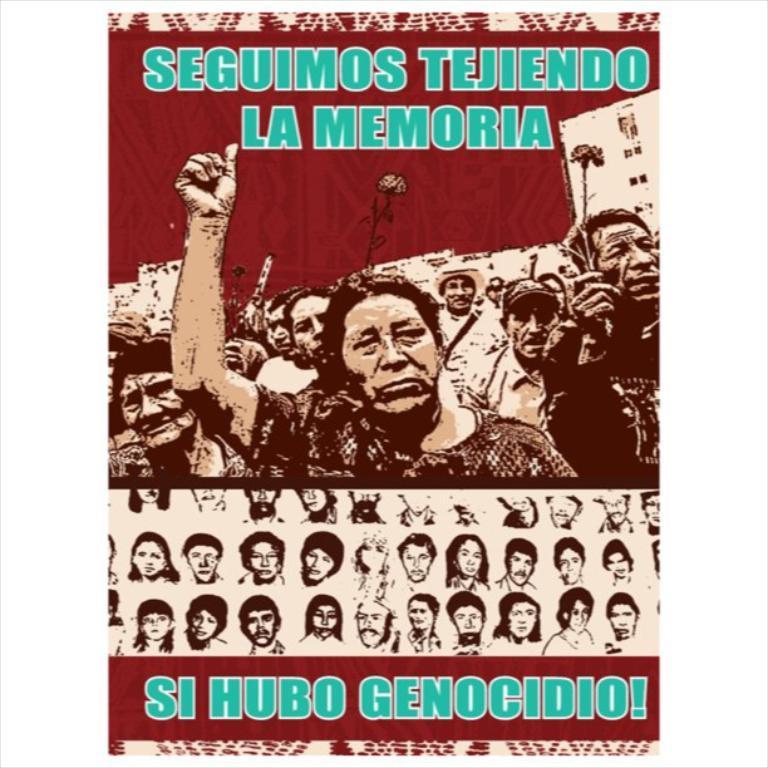How would you summarize this image in a sentence or two? This image consists of a poster. On this poster, I can see some text and few images of persons. 